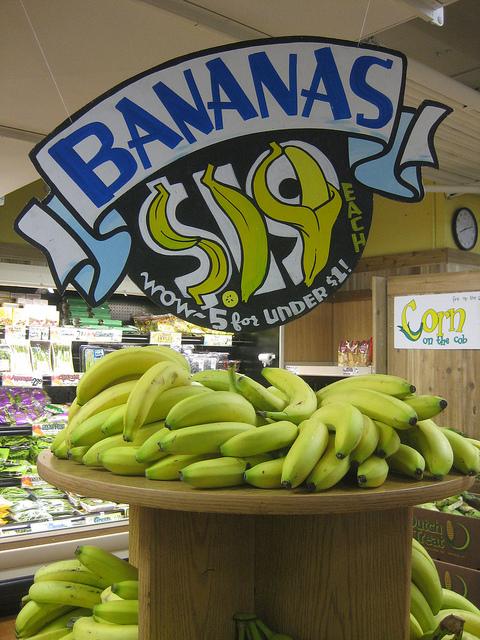How much do these bananas cost?
Be succinct. .19. Are the bananas for sale?
Be succinct. Yes. Is someone selling the bananas in the US?
Quick response, please. Yes. How much are the baby bananas?
Keep it brief. $.19. Is that cheap?
Be succinct. Yes. Where is a clock to tell time?
Answer briefly. Wall. Would 5 of this fruit cost $1.01?
Concise answer only. No. What color are the bananas?
Quick response, please. Yellow. 